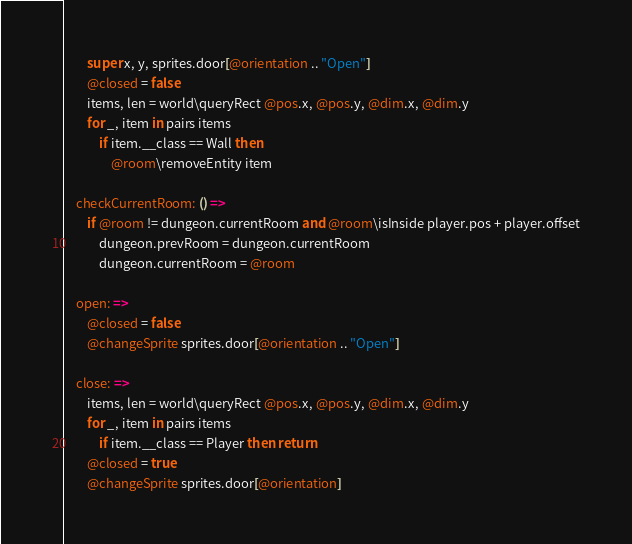<code> <loc_0><loc_0><loc_500><loc_500><_MoonScript_>        super x, y, sprites.door[@orientation .. "Open"]
        @closed = false
        items, len = world\queryRect @pos.x, @pos.y, @dim.x, @dim.y
        for _, item in pairs items
            if item.__class == Wall then
                @room\removeEntity item

    checkCurrentRoom: () =>
        if @room != dungeon.currentRoom and @room\isInside player.pos + player.offset
            dungeon.prevRoom = dungeon.currentRoom
            dungeon.currentRoom = @room

    open: =>
        @closed = false
        @changeSprite sprites.door[@orientation .. "Open"]

    close: =>
        items, len = world\queryRect @pos.x, @pos.y, @dim.x, @dim.y
        for _, item in pairs items
            if item.__class == Player then return
        @closed = true
        @changeSprite sprites.door[@orientation]</code> 